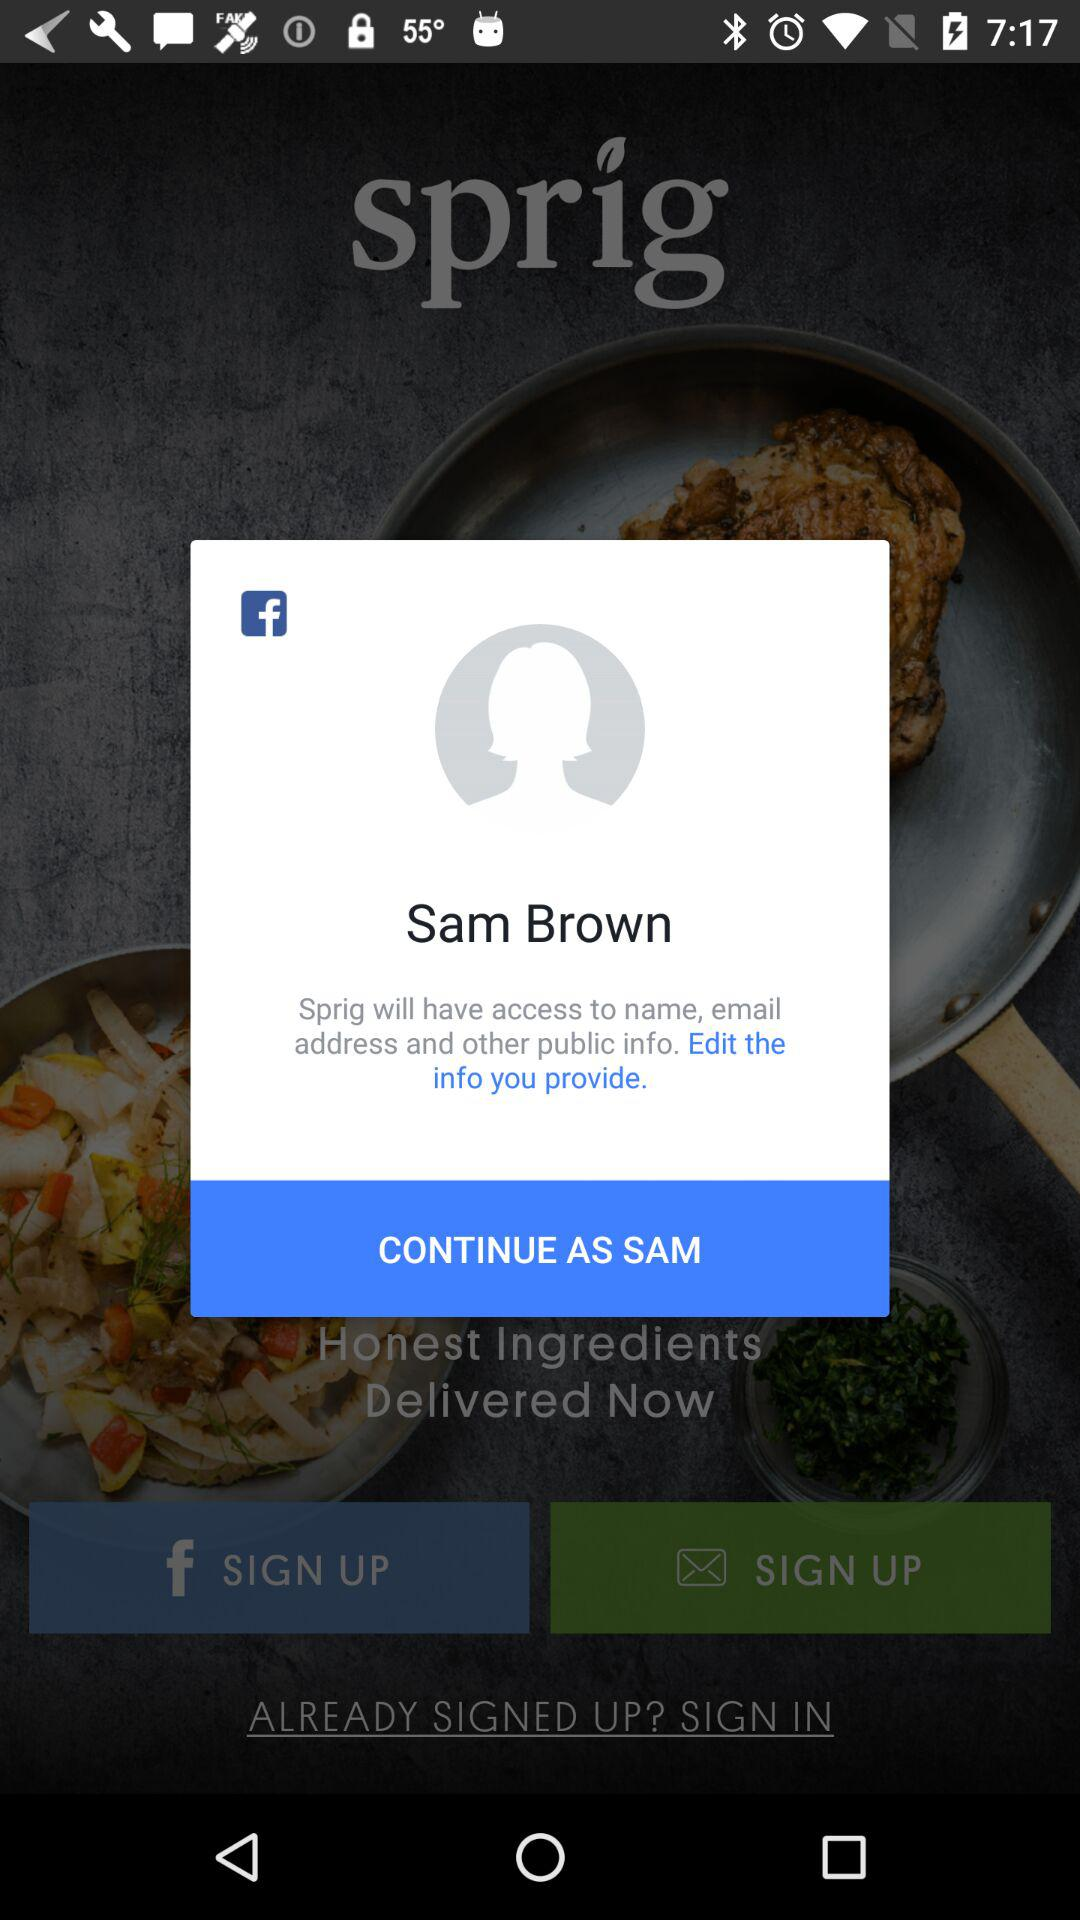What is the name of the user? The name of the user is Sam Brown. 